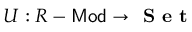<formula> <loc_0><loc_0><loc_500><loc_500>U \colon R - { M o d } \to { S e t }</formula> 